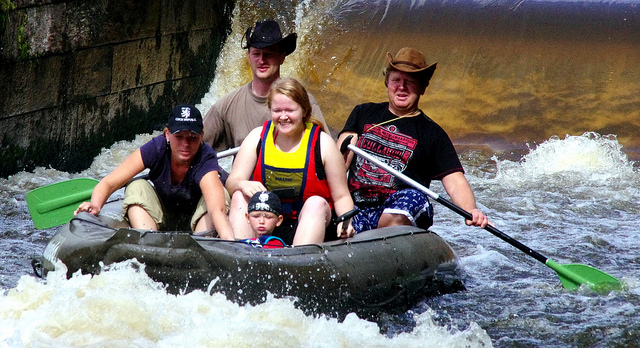How many people are on the raft, and what are they wearing? There are five people on the raft. Starting from the front, one person is wearing a black hat, a grey t-shirt, and sunglasses. Beside him, a young child is in a blue and white striped shirt. Just behind them, there’s a woman in a yellow life jacket, a man in a cap, and another in a dark red cap and a black t-shirt. Safety seems to be a priority as most individuals have life vests on. 